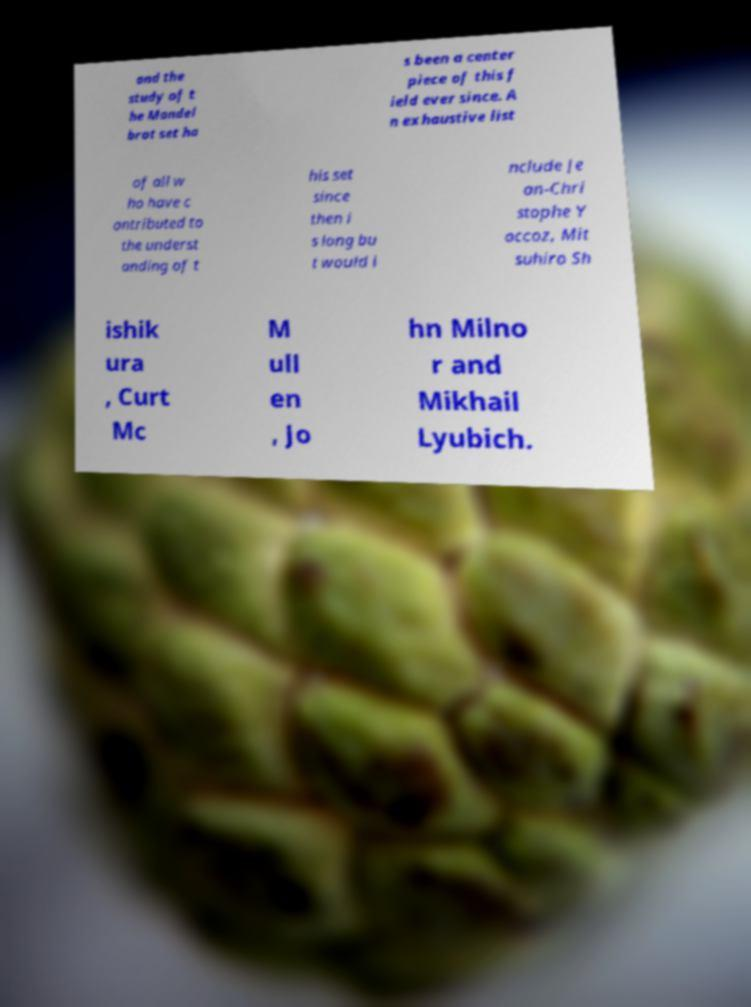Please read and relay the text visible in this image. What does it say? and the study of t he Mandel brot set ha s been a center piece of this f ield ever since. A n exhaustive list of all w ho have c ontributed to the underst anding of t his set since then i s long bu t would i nclude Je an-Chri stophe Y occoz, Mit suhiro Sh ishik ura , Curt Mc M ull en , Jo hn Milno r and Mikhail Lyubich. 